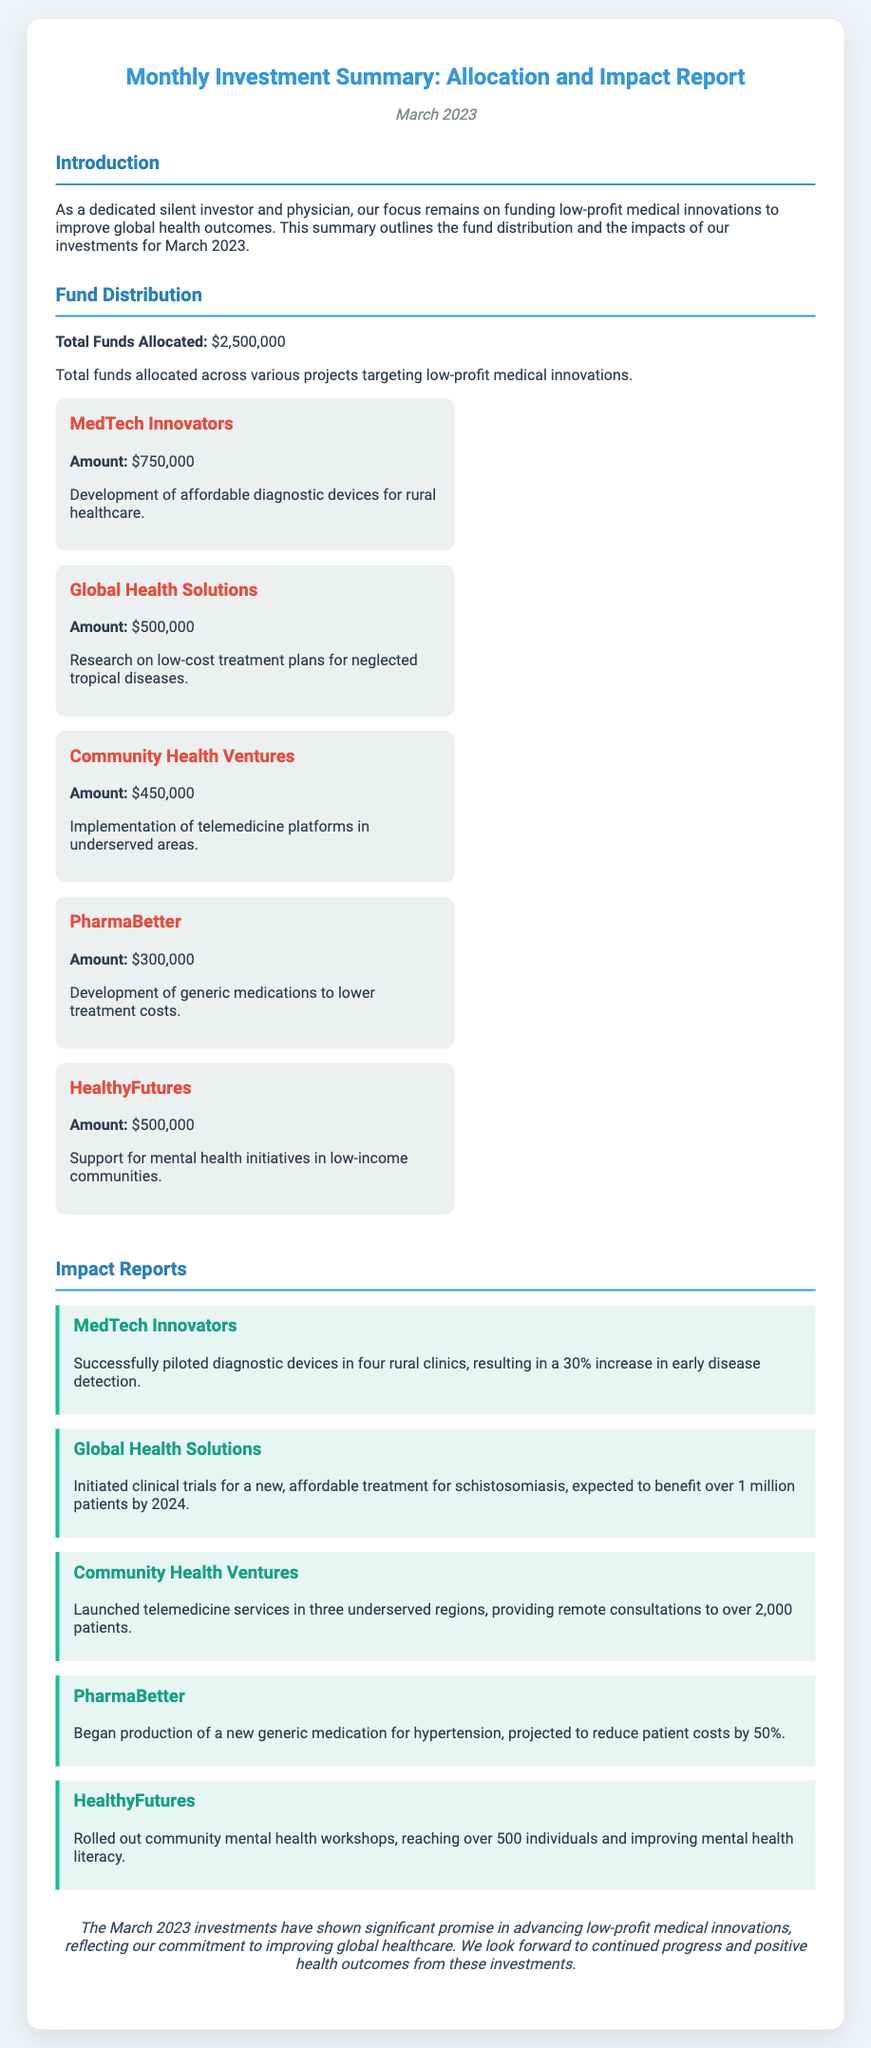What is the total funds allocated? The total funds allocated is explicitly stated in the document as $2,500,000.
Answer: $2,500,000 How much was allocated to MedTech Innovators? The document details that MedTech Innovators received $750,000 in funds.
Answer: $750,000 What project supports mental health initiatives? The document indicates HealthyFutures as the project that supports mental health initiatives.
Answer: HealthyFutures What percentage increase in early disease detection was reported by MedTech Innovators? The document mentions a 30% increase in early disease detection resulting from the projects.
Answer: 30% How many patients were provided remote consultations by Community Health Ventures? According to the document, Community Health Ventures provided remote consultations to over 2,000 patients.
Answer: over 2,000 What was the projected cost reduction for hypertension patients by PharmaBetter? The document states that PharmaBetter is projected to reduce patient costs by 50%.
Answer: 50% How many individuals were reached by HealthyFutures mental health workshops? The document reports that HealthyFutures reached over 500 individuals through mental health workshops.
Answer: over 500 What is the expected benefit of the treatment for schistosomiasis from Global Health Solutions? The document states that the expected benefit is for over 1 million patients by 2024.
Answer: over 1 million 